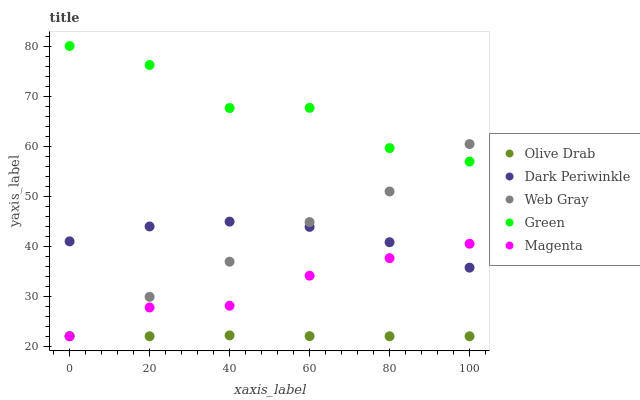Does Olive Drab have the minimum area under the curve?
Answer yes or no. Yes. Does Green have the maximum area under the curve?
Answer yes or no. Yes. Does Web Gray have the minimum area under the curve?
Answer yes or no. No. Does Web Gray have the maximum area under the curve?
Answer yes or no. No. Is Olive Drab the smoothest?
Answer yes or no. Yes. Is Green the roughest?
Answer yes or no. Yes. Is Web Gray the smoothest?
Answer yes or no. No. Is Web Gray the roughest?
Answer yes or no. No. Does Magenta have the lowest value?
Answer yes or no. Yes. Does Green have the lowest value?
Answer yes or no. No. Does Green have the highest value?
Answer yes or no. Yes. Does Web Gray have the highest value?
Answer yes or no. No. Is Olive Drab less than Green?
Answer yes or no. Yes. Is Dark Periwinkle greater than Olive Drab?
Answer yes or no. Yes. Does Magenta intersect Web Gray?
Answer yes or no. Yes. Is Magenta less than Web Gray?
Answer yes or no. No. Is Magenta greater than Web Gray?
Answer yes or no. No. Does Olive Drab intersect Green?
Answer yes or no. No. 